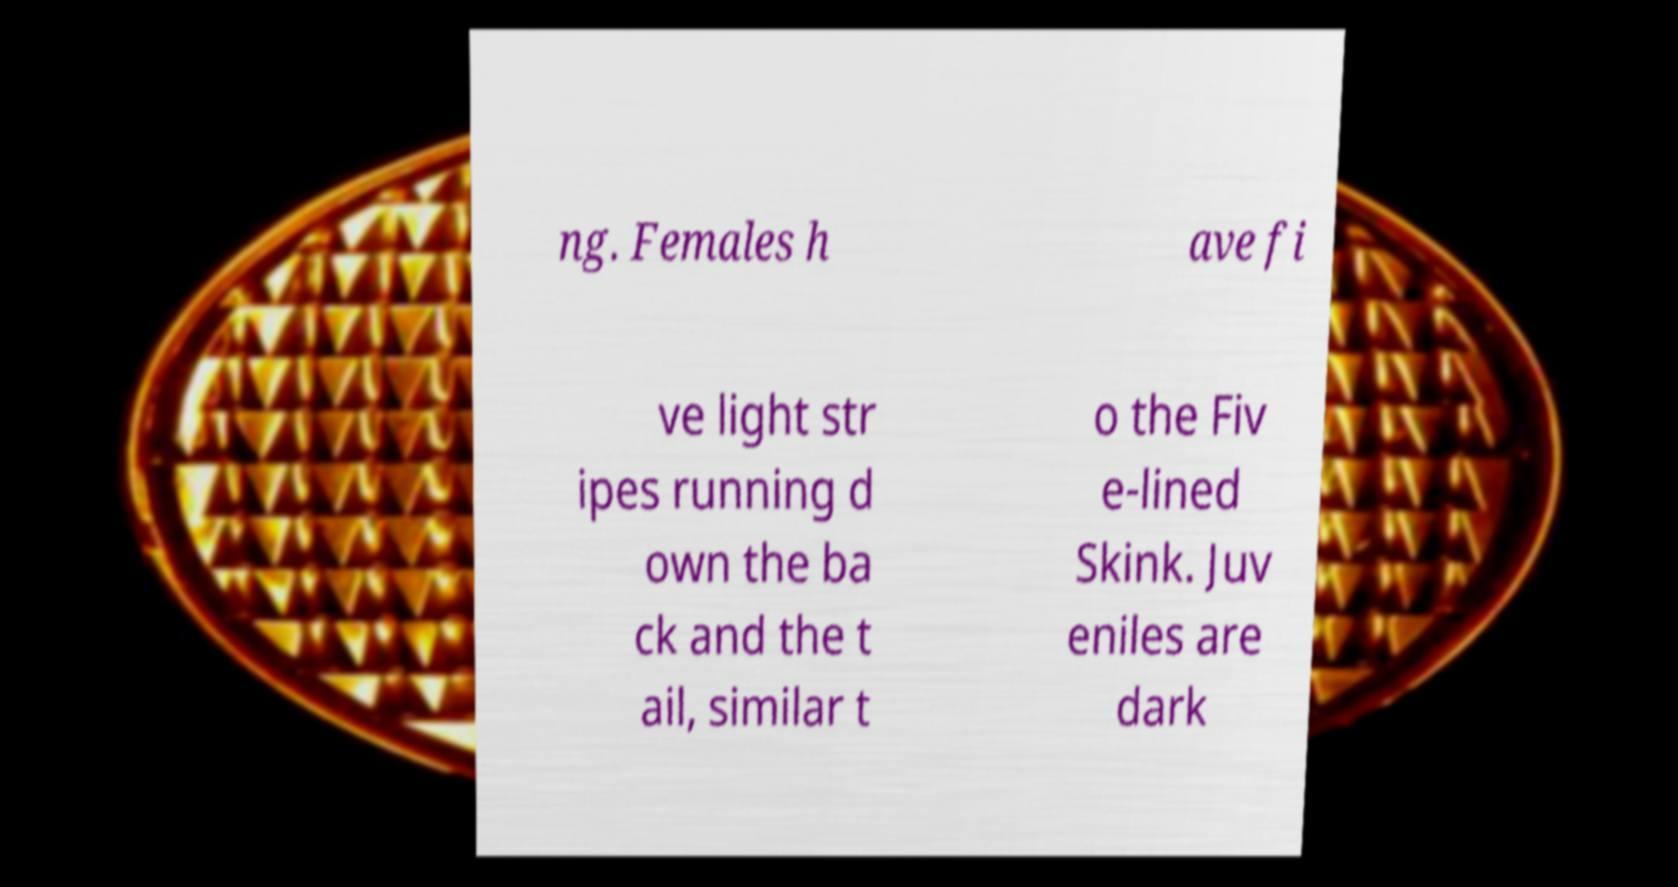For documentation purposes, I need the text within this image transcribed. Could you provide that? ng. Females h ave fi ve light str ipes running d own the ba ck and the t ail, similar t o the Fiv e-lined Skink. Juv eniles are dark 